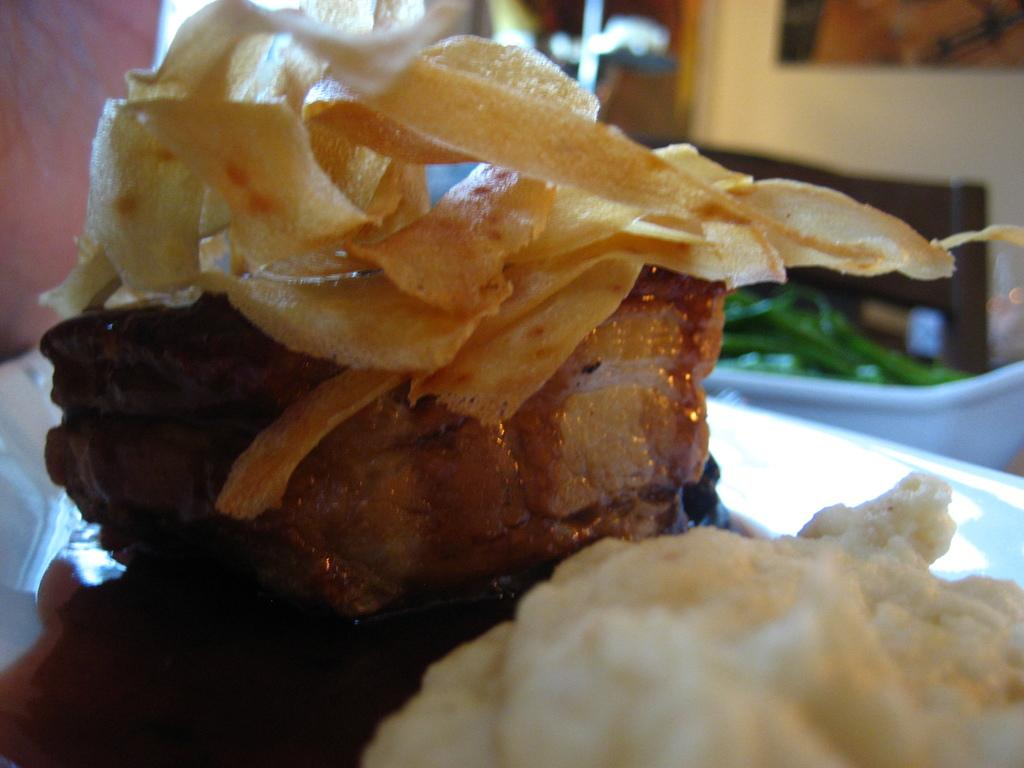What types of items can be seen in the image? There are food items in the image. What is the color of the surface on which the food items are placed? The food items are on a white surface. What type of soda is being served by the manager in the image? There is no soda or manager present in the image; it only features food items on a white surface. 